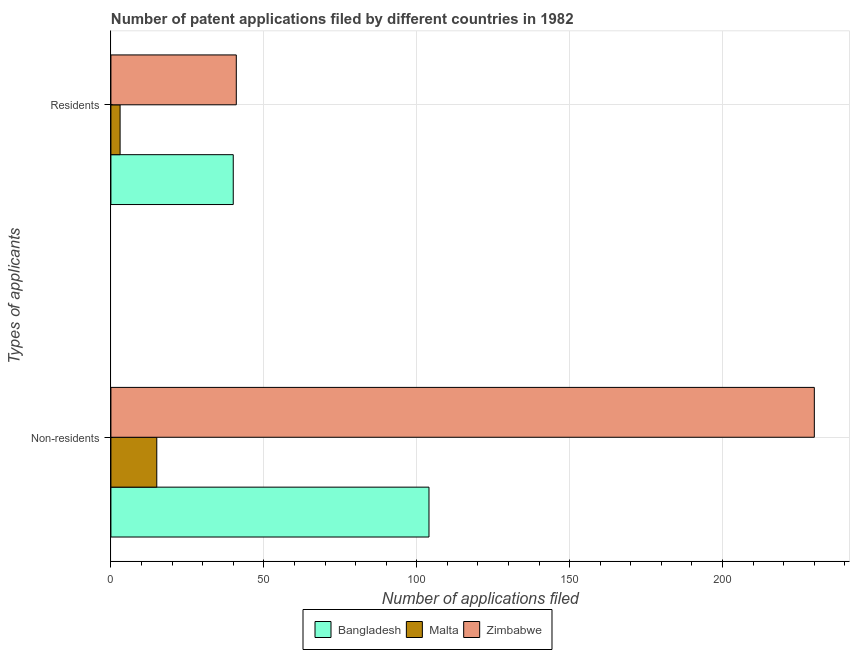How many different coloured bars are there?
Your answer should be compact. 3. How many groups of bars are there?
Your answer should be compact. 2. How many bars are there on the 2nd tick from the top?
Provide a short and direct response. 3. How many bars are there on the 2nd tick from the bottom?
Keep it short and to the point. 3. What is the label of the 1st group of bars from the top?
Make the answer very short. Residents. What is the number of patent applications by residents in Malta?
Your answer should be compact. 3. Across all countries, what is the maximum number of patent applications by non residents?
Provide a short and direct response. 230. Across all countries, what is the minimum number of patent applications by non residents?
Keep it short and to the point. 15. In which country was the number of patent applications by non residents maximum?
Your response must be concise. Zimbabwe. In which country was the number of patent applications by non residents minimum?
Provide a succinct answer. Malta. What is the total number of patent applications by residents in the graph?
Make the answer very short. 84. What is the difference between the number of patent applications by residents in Bangladesh and that in Malta?
Keep it short and to the point. 37. What is the difference between the number of patent applications by residents in Malta and the number of patent applications by non residents in Bangladesh?
Give a very brief answer. -101. What is the difference between the number of patent applications by residents and number of patent applications by non residents in Malta?
Keep it short and to the point. -12. What is the ratio of the number of patent applications by residents in Zimbabwe to that in Bangladesh?
Give a very brief answer. 1.02. Is the number of patent applications by residents in Malta less than that in Zimbabwe?
Provide a short and direct response. Yes. What does the 1st bar from the top in Residents represents?
Your response must be concise. Zimbabwe. What does the 1st bar from the bottom in Residents represents?
Make the answer very short. Bangladesh. How many bars are there?
Keep it short and to the point. 6. Are all the bars in the graph horizontal?
Provide a short and direct response. Yes. Does the graph contain any zero values?
Your answer should be very brief. No. What is the title of the graph?
Provide a succinct answer. Number of patent applications filed by different countries in 1982. Does "Philippines" appear as one of the legend labels in the graph?
Offer a very short reply. No. What is the label or title of the X-axis?
Your response must be concise. Number of applications filed. What is the label or title of the Y-axis?
Give a very brief answer. Types of applicants. What is the Number of applications filed in Bangladesh in Non-residents?
Your answer should be compact. 104. What is the Number of applications filed of Malta in Non-residents?
Provide a succinct answer. 15. What is the Number of applications filed of Zimbabwe in Non-residents?
Your answer should be very brief. 230. What is the Number of applications filed in Zimbabwe in Residents?
Your response must be concise. 41. Across all Types of applicants, what is the maximum Number of applications filed in Bangladesh?
Provide a succinct answer. 104. Across all Types of applicants, what is the maximum Number of applications filed of Zimbabwe?
Provide a short and direct response. 230. Across all Types of applicants, what is the minimum Number of applications filed of Bangladesh?
Your answer should be compact. 40. Across all Types of applicants, what is the minimum Number of applications filed in Malta?
Your answer should be compact. 3. Across all Types of applicants, what is the minimum Number of applications filed in Zimbabwe?
Keep it short and to the point. 41. What is the total Number of applications filed of Bangladesh in the graph?
Your answer should be compact. 144. What is the total Number of applications filed of Zimbabwe in the graph?
Your answer should be very brief. 271. What is the difference between the Number of applications filed of Malta in Non-residents and that in Residents?
Make the answer very short. 12. What is the difference between the Number of applications filed in Zimbabwe in Non-residents and that in Residents?
Provide a succinct answer. 189. What is the difference between the Number of applications filed in Bangladesh in Non-residents and the Number of applications filed in Malta in Residents?
Keep it short and to the point. 101. What is the average Number of applications filed in Bangladesh per Types of applicants?
Ensure brevity in your answer.  72. What is the average Number of applications filed in Malta per Types of applicants?
Ensure brevity in your answer.  9. What is the average Number of applications filed of Zimbabwe per Types of applicants?
Your response must be concise. 135.5. What is the difference between the Number of applications filed in Bangladesh and Number of applications filed in Malta in Non-residents?
Offer a very short reply. 89. What is the difference between the Number of applications filed of Bangladesh and Number of applications filed of Zimbabwe in Non-residents?
Offer a very short reply. -126. What is the difference between the Number of applications filed in Malta and Number of applications filed in Zimbabwe in Non-residents?
Make the answer very short. -215. What is the difference between the Number of applications filed of Bangladesh and Number of applications filed of Malta in Residents?
Ensure brevity in your answer.  37. What is the difference between the Number of applications filed in Malta and Number of applications filed in Zimbabwe in Residents?
Keep it short and to the point. -38. What is the ratio of the Number of applications filed in Malta in Non-residents to that in Residents?
Provide a short and direct response. 5. What is the ratio of the Number of applications filed of Zimbabwe in Non-residents to that in Residents?
Provide a short and direct response. 5.61. What is the difference between the highest and the second highest Number of applications filed of Bangladesh?
Make the answer very short. 64. What is the difference between the highest and the second highest Number of applications filed of Malta?
Your answer should be very brief. 12. What is the difference between the highest and the second highest Number of applications filed in Zimbabwe?
Your answer should be very brief. 189. What is the difference between the highest and the lowest Number of applications filed in Bangladesh?
Offer a terse response. 64. What is the difference between the highest and the lowest Number of applications filed in Malta?
Give a very brief answer. 12. What is the difference between the highest and the lowest Number of applications filed in Zimbabwe?
Your response must be concise. 189. 